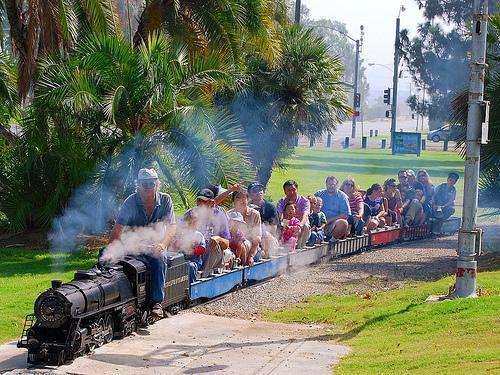How many passenger cars?
Give a very brief answer. 7. How many elephants have 2 people riding them?
Give a very brief answer. 0. 